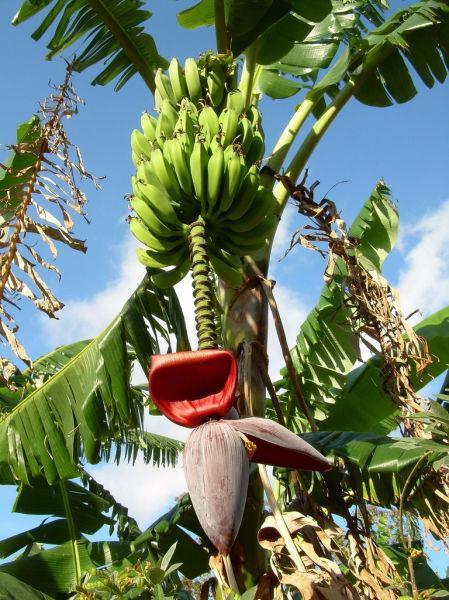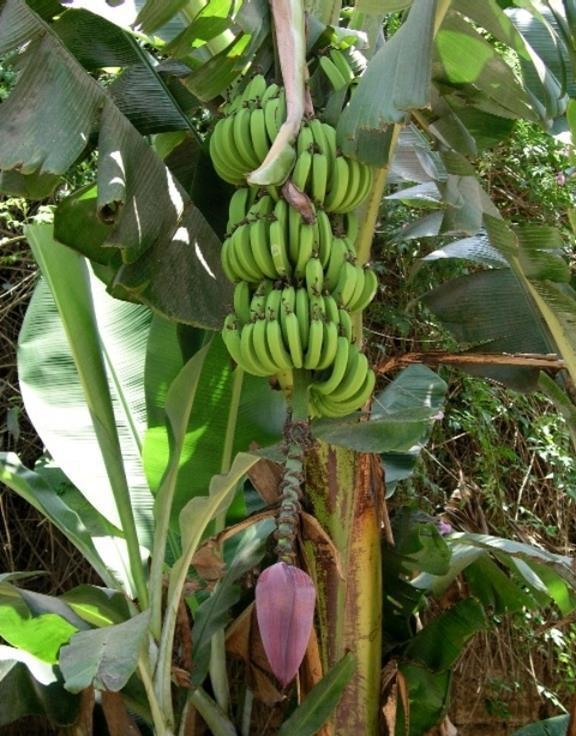The first image is the image on the left, the second image is the image on the right. Given the left and right images, does the statement "One image shows a large purple bud with no open petals hanging under multiple tiers of green bananas." hold true? Answer yes or no. Yes. The first image is the image on the left, the second image is the image on the right. Given the left and right images, does the statement "The image on the left has at least one dark red petal" hold true? Answer yes or no. Yes. 